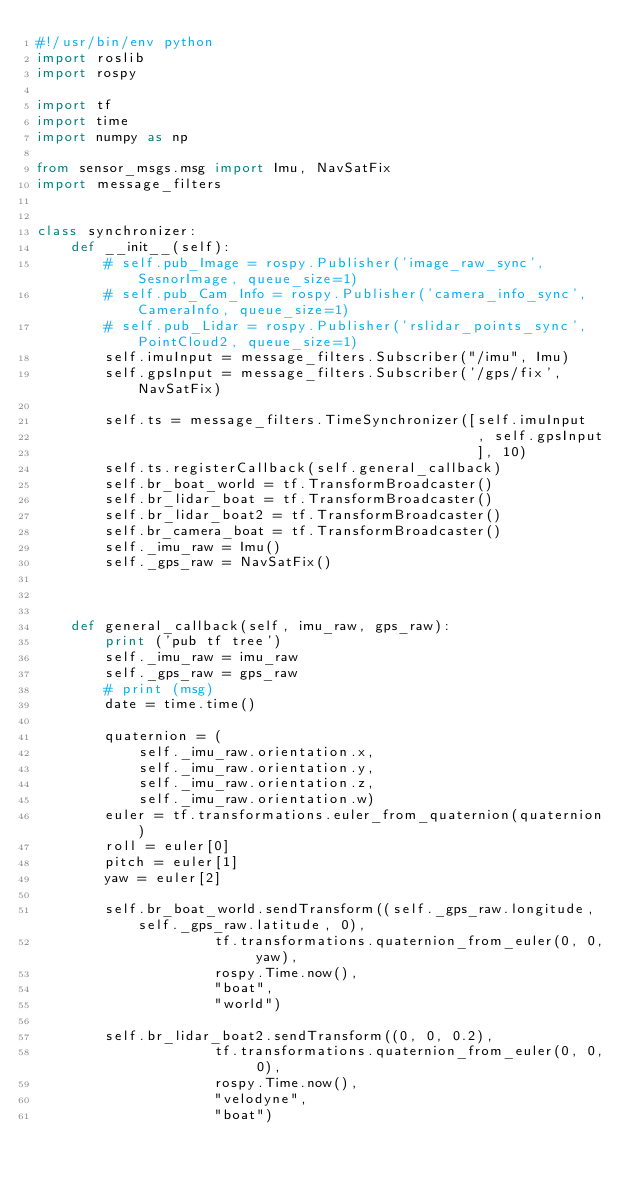<code> <loc_0><loc_0><loc_500><loc_500><_Python_>#!/usr/bin/env python  
import roslib
import rospy

import tf
import time
import numpy as np

from sensor_msgs.msg import Imu, NavSatFix
import message_filters


class synchronizer:
    def __init__(self):
        # self.pub_Image = rospy.Publisher('image_raw_sync', SesnorImage, queue_size=1)
        # self.pub_Cam_Info = rospy.Publisher('camera_info_sync', CameraInfo, queue_size=1)
        # self.pub_Lidar = rospy.Publisher('rslidar_points_sync', PointCloud2, queue_size=1)
        self.imuInput = message_filters.Subscriber("/imu", Imu)
        self.gpsInput = message_filters.Subscriber('/gps/fix', NavSatFix)

        self.ts = message_filters.TimeSynchronizer([self.imuInput
                                                    , self.gpsInput
                                                    ], 10)
        self.ts.registerCallback(self.general_callback)
        self.br_boat_world = tf.TransformBroadcaster()
        self.br_lidar_boat = tf.TransformBroadcaster()
        self.br_lidar_boat2 = tf.TransformBroadcaster()
        self.br_camera_boat = tf.TransformBroadcaster()
        self._imu_raw = Imu()
        self._gps_raw = NavSatFix()
        

        
    def general_callback(self, imu_raw, gps_raw):
        print ('pub tf tree')
        self._imu_raw = imu_raw
        self._gps_raw = gps_raw
        # print (msg)
        date = time.time()

        quaternion = (
            self._imu_raw.orientation.x,
            self._imu_raw.orientation.y,
            self._imu_raw.orientation.z,
            self._imu_raw.orientation.w)
        euler = tf.transformations.euler_from_quaternion(quaternion)
        roll = euler[0]
        pitch = euler[1]
        yaw = euler[2]

        self.br_boat_world.sendTransform((self._gps_raw.longitude, self._gps_raw.latitude, 0),
                     tf.transformations.quaternion_from_euler(0, 0, yaw),
                     rospy.Time.now(),
                     "boat",
                     "world")

        self.br_lidar_boat2.sendTransform((0, 0, 0.2),
                     tf.transformations.quaternion_from_euler(0, 0, 0),
                     rospy.Time.now(),
                     "velodyne",
                     "boat")
        </code> 